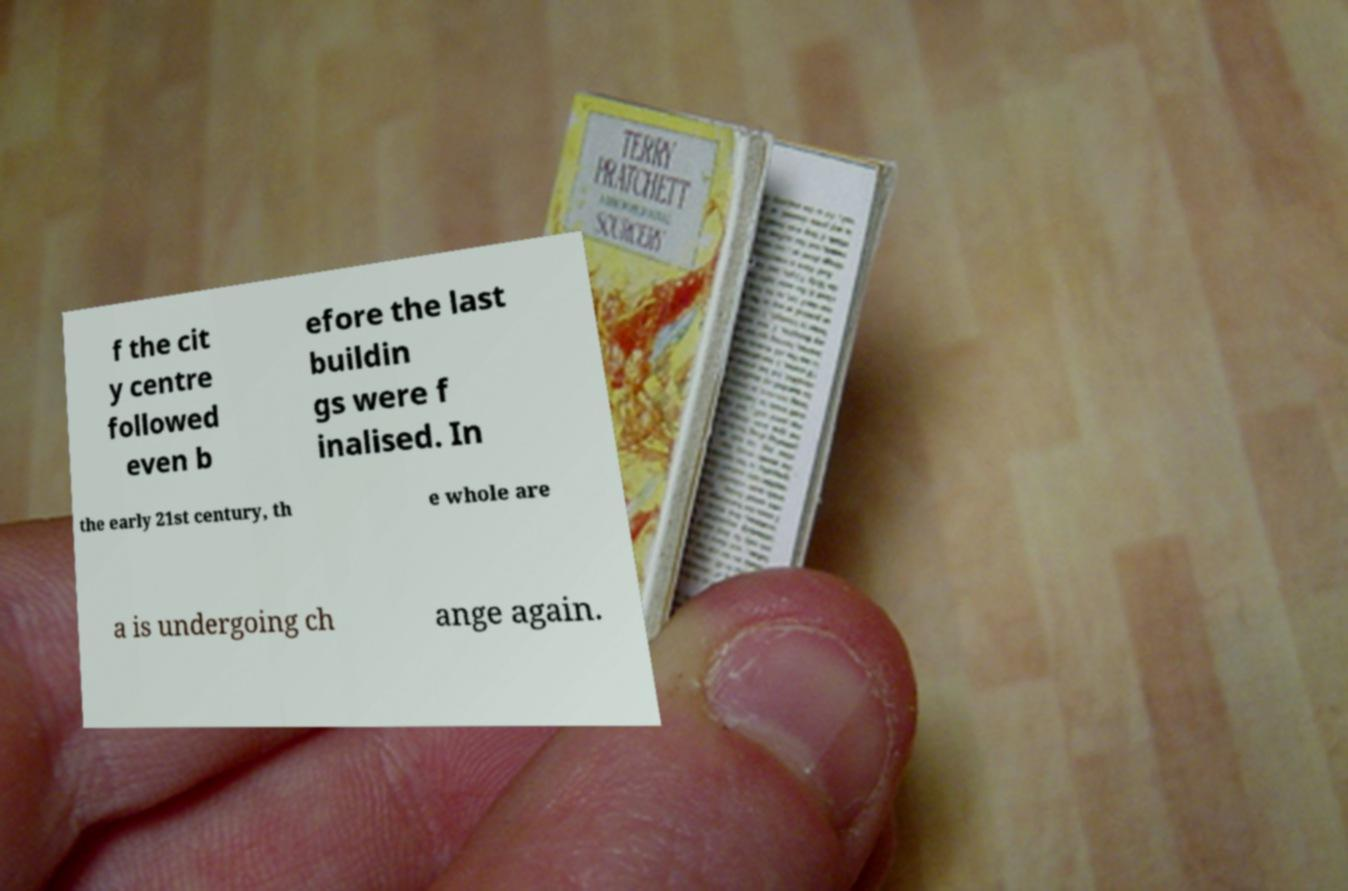Please identify and transcribe the text found in this image. f the cit y centre followed even b efore the last buildin gs were f inalised. In the early 21st century, th e whole are a is undergoing ch ange again. 